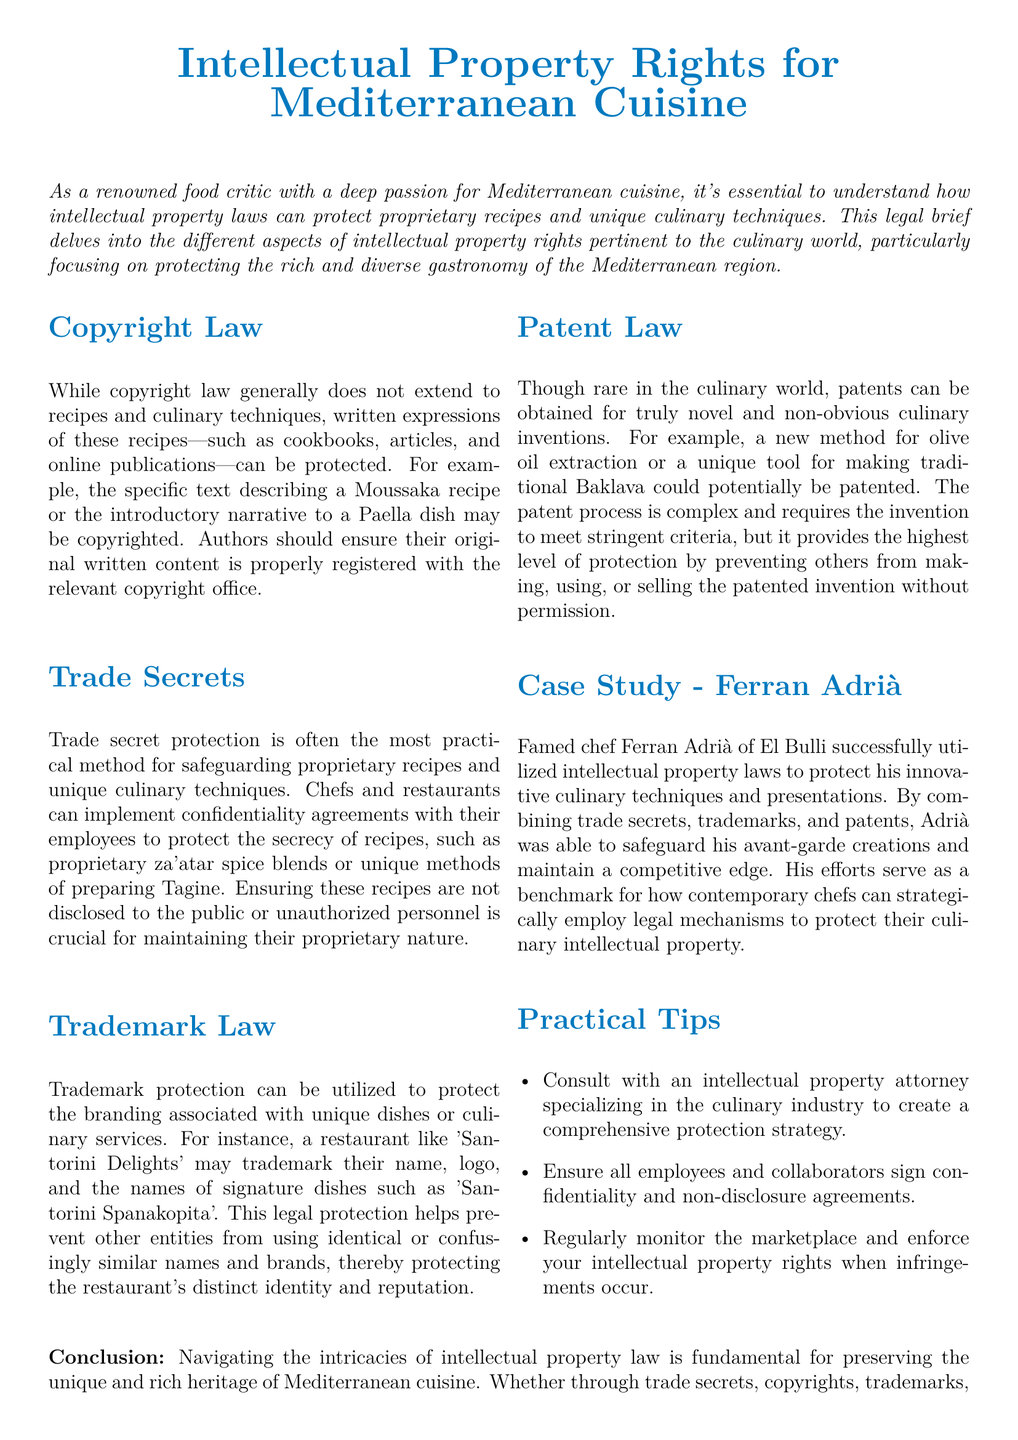What is the main focus of the legal brief? The main focus of the legal brief is on intellectual property rights concerning proprietary recipes and unique culinary techniques specific to Mediterranean cuisine.
Answer: Intellectual property rights Which legal protection can cover written descriptions of recipes? Copyright law can protect the written expressions of recipes, such as cookbooks and articles.
Answer: Copyright law What type of intellectual property protection is typically most practical for recipes? Trade secret protection is often the most practical method for safeguarding proprietary recipes.
Answer: Trade secrets Which chef is mentioned as a case study for utilizing intellectual property laws? The legal brief mentions Ferran Adrià as a case study.
Answer: Ferran Adrià What type of legal protection can be used for the branding of recipes? Trademark protection can be utilized to protect the branding associated with unique dishes.
Answer: Trademark protection What should chefs do to ensure their proprietary recipes remain secret? Chefs should implement confidentiality agreements with their employees.
Answer: Confidentiality agreements What is a potential legal protection for truly novel culinary inventions? Patents can be obtained for truly novel and non-obvious culinary inventions.
Answer: Patents What advice is given regarding monitoring for intellectual property rights violations? It is advised to regularly monitor the marketplace and enforce your intellectual property rights when infringements occur.
Answer: Regularly monitor the marketplace How many practical tips are provided in the document? The document provides three practical tips.
Answer: Three 